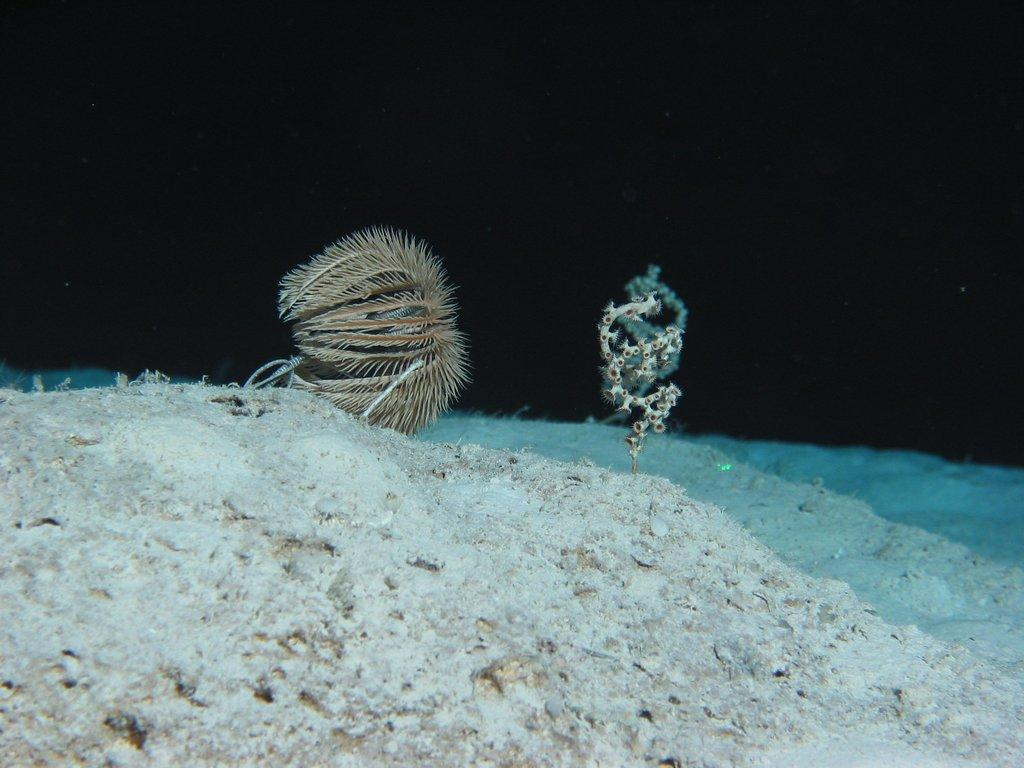What type of surface is visible in the image? There is sand in the image. What can be seen in the middle of the image? There are plants in the middle of the image. Where is the jar located in the image? There is no jar present in the image. Can you see any people or books in the image? No, there are no people or books visible in the image. 